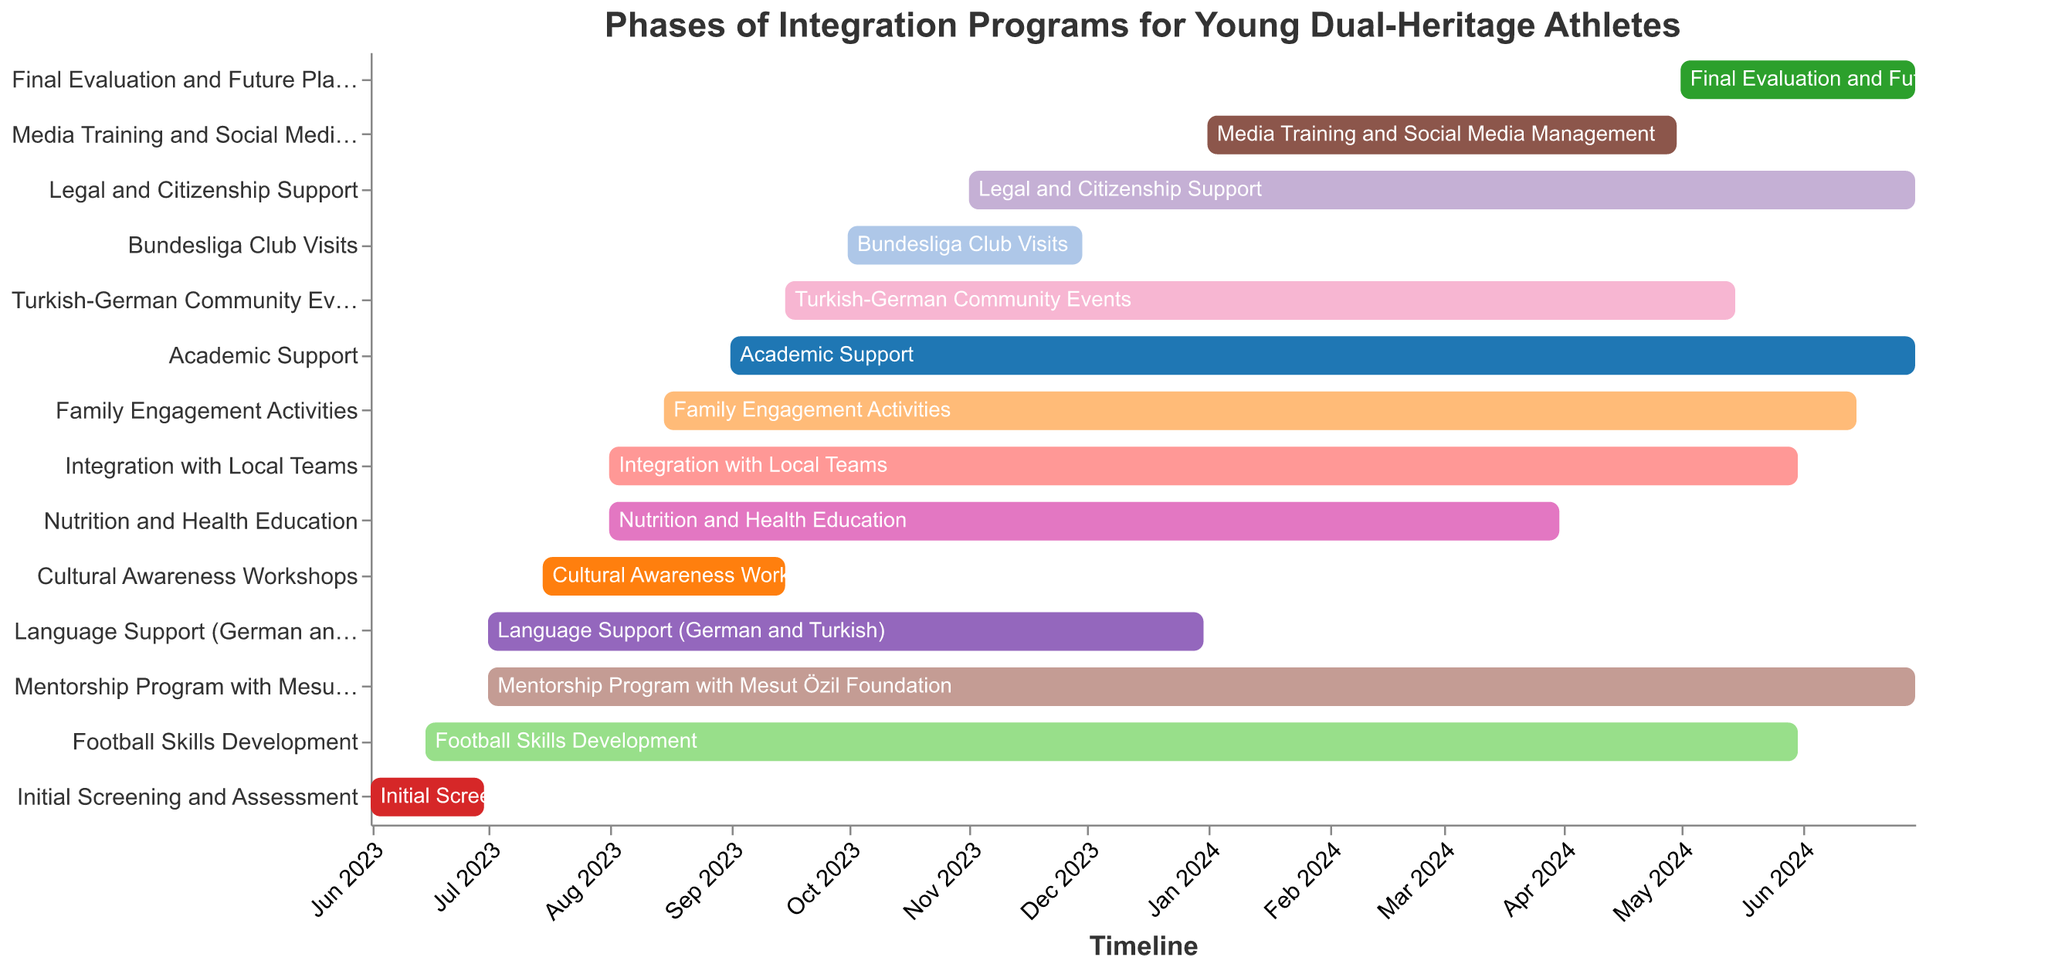What is the title of the chart? The title of the chart is displayed at the top center of the figure.
Answer: Phases of Integration Programs for Young Dual-Heritage Athletes Which task starts first? The task that starts first is the one with the earliest start date on the x-axis.
Answer: Initial Screening and Assessment How long does the "Language Support (German and Turkish)" phase last? Calculate the duration between the start date (July 1, 2023) and the end date (December 31, 2023).
Answer: 6 months Which two tasks have the latest end dates? Identify tasks with end dates furthest to the right on the x-axis, which are "Academic Support" and "Mentorship Program with Mesut Özil Foundation".
Answer: Academic Support and Mentorship Program with Mesut Özil Foundation How many tasks start in August 2023? Count the number of tasks with start dates in August 2023 by examining the x-axis position representing August 2023.
Answer: 3 Which tasks overlap with the "Cultural Awareness Workshops"? Examine the start and end dates of all tasks and identify those whose time frames intersect with "Cultural Awareness Workshops" (July 15, 2023, to September 15, 2023).
Answer: Language Support (German and Turkish), Football Skills Development, Mentorship Program with Mesut Özil Foundation When does the "Final Evaluation and Future Planning" phase end? Locate the end date for "Final Evaluation and Future Planning" on the x-axis.
Answer: June 30, 2024 What is the shortest phase in the program? Identify the task with the smallest duration by comparing the length of the bars.
Answer: Initial Screening and Assessment Which task starts immediately after "Initial Screening and Assessment" ends? Observe which task's start date comes right after the end date of "Initial Screening and Assessment" (June 30, 2023).
Answer: Language Support (German and Turkish) What is the duration of the "Football Skills Development" phase? Calculate the duration between its start date (June 15, 2023) and its end date (May 31, 2024).
Answer: 11.5 months 